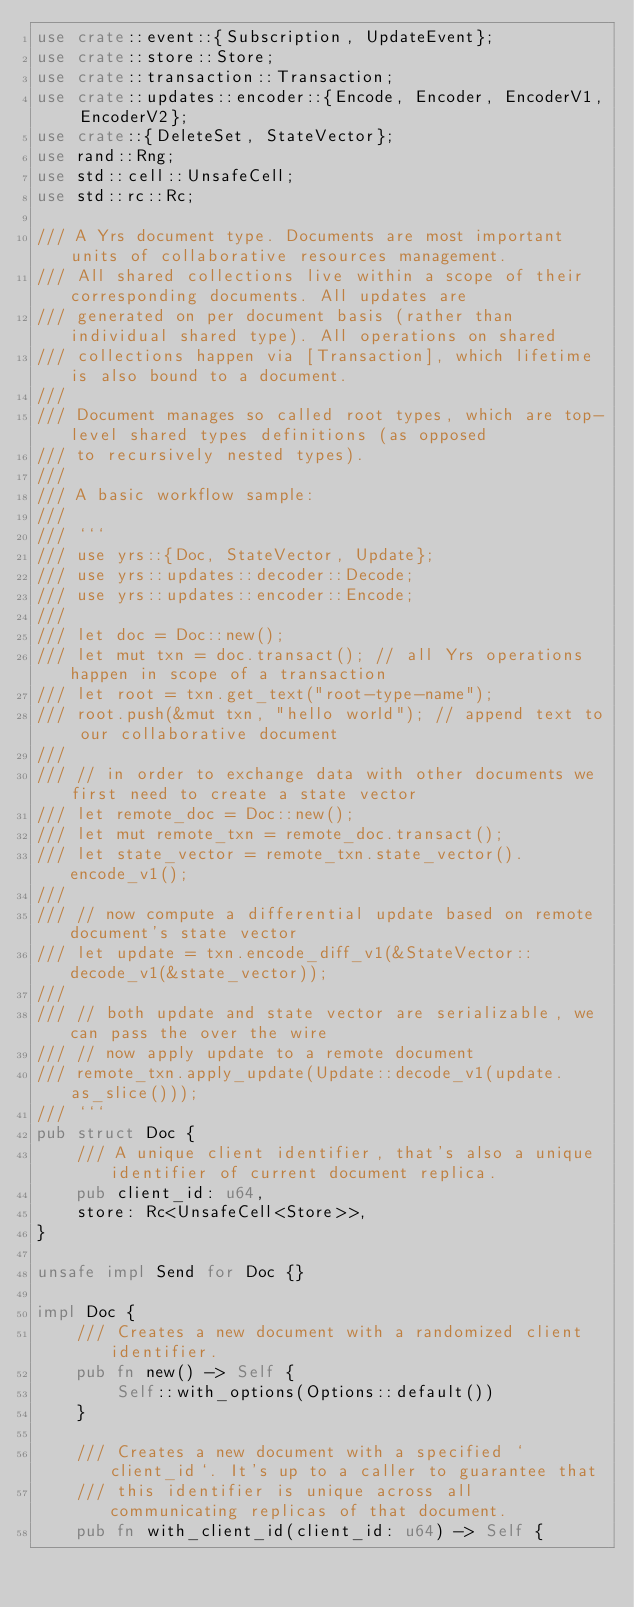Convert code to text. <code><loc_0><loc_0><loc_500><loc_500><_Rust_>use crate::event::{Subscription, UpdateEvent};
use crate::store::Store;
use crate::transaction::Transaction;
use crate::updates::encoder::{Encode, Encoder, EncoderV1, EncoderV2};
use crate::{DeleteSet, StateVector};
use rand::Rng;
use std::cell::UnsafeCell;
use std::rc::Rc;

/// A Yrs document type. Documents are most important units of collaborative resources management.
/// All shared collections live within a scope of their corresponding documents. All updates are
/// generated on per document basis (rather than individual shared type). All operations on shared
/// collections happen via [Transaction], which lifetime is also bound to a document.
///
/// Document manages so called root types, which are top-level shared types definitions (as opposed
/// to recursively nested types).
///
/// A basic workflow sample:
///
/// ```
/// use yrs::{Doc, StateVector, Update};
/// use yrs::updates::decoder::Decode;
/// use yrs::updates::encoder::Encode;
///
/// let doc = Doc::new();
/// let mut txn = doc.transact(); // all Yrs operations happen in scope of a transaction
/// let root = txn.get_text("root-type-name");
/// root.push(&mut txn, "hello world"); // append text to our collaborative document
///
/// // in order to exchange data with other documents we first need to create a state vector
/// let remote_doc = Doc::new();
/// let mut remote_txn = remote_doc.transact();
/// let state_vector = remote_txn.state_vector().encode_v1();
///
/// // now compute a differential update based on remote document's state vector
/// let update = txn.encode_diff_v1(&StateVector::decode_v1(&state_vector));
///
/// // both update and state vector are serializable, we can pass the over the wire
/// // now apply update to a remote document
/// remote_txn.apply_update(Update::decode_v1(update.as_slice()));
/// ```
pub struct Doc {
    /// A unique client identifier, that's also a unique identifier of current document replica.
    pub client_id: u64,
    store: Rc<UnsafeCell<Store>>,
}

unsafe impl Send for Doc {}

impl Doc {
    /// Creates a new document with a randomized client identifier.
    pub fn new() -> Self {
        Self::with_options(Options::default())
    }

    /// Creates a new document with a specified `client_id`. It's up to a caller to guarantee that
    /// this identifier is unique across all communicating replicas of that document.
    pub fn with_client_id(client_id: u64) -> Self {</code> 